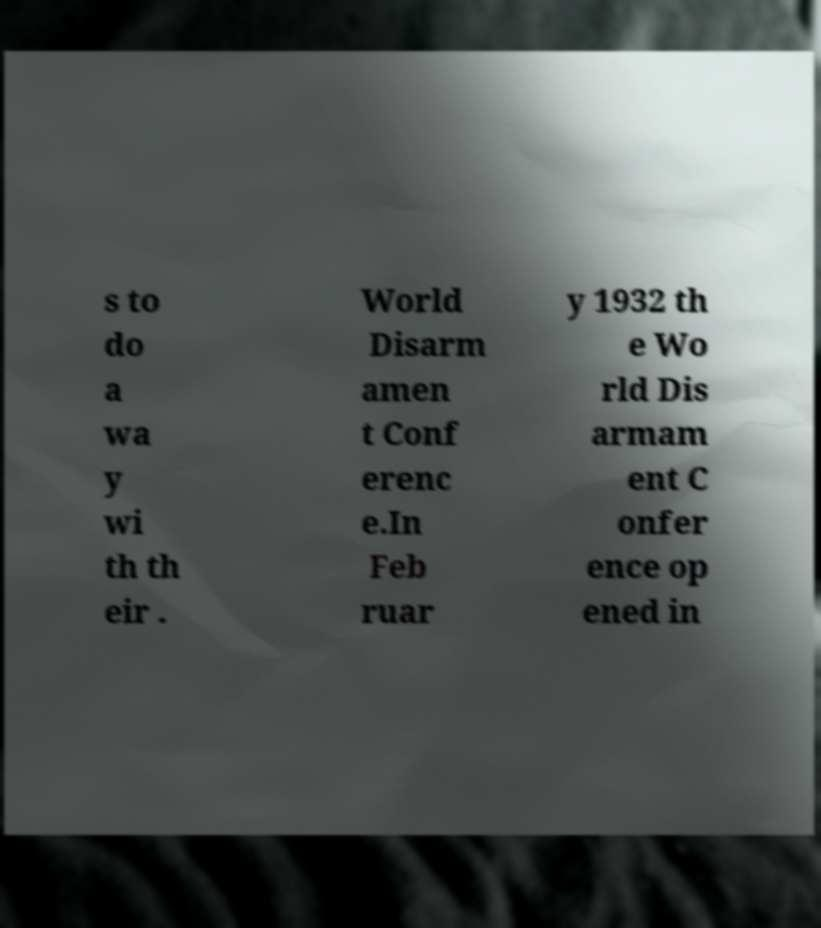Could you extract and type out the text from this image? s to do a wa y wi th th eir . World Disarm amen t Conf erenc e.In Feb ruar y 1932 th e Wo rld Dis armam ent C onfer ence op ened in 